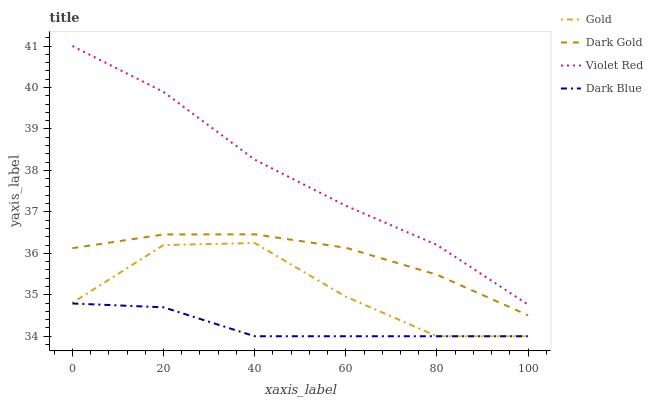Does Dark Blue have the minimum area under the curve?
Answer yes or no. Yes. Does Violet Red have the maximum area under the curve?
Answer yes or no. Yes. Does Gold have the minimum area under the curve?
Answer yes or no. No. Does Gold have the maximum area under the curve?
Answer yes or no. No. Is Dark Blue the smoothest?
Answer yes or no. Yes. Is Gold the roughest?
Answer yes or no. Yes. Is Violet Red the smoothest?
Answer yes or no. No. Is Violet Red the roughest?
Answer yes or no. No. Does Dark Blue have the lowest value?
Answer yes or no. Yes. Does Violet Red have the lowest value?
Answer yes or no. No. Does Violet Red have the highest value?
Answer yes or no. Yes. Does Gold have the highest value?
Answer yes or no. No. Is Dark Gold less than Violet Red?
Answer yes or no. Yes. Is Dark Gold greater than Dark Blue?
Answer yes or no. Yes. Does Gold intersect Dark Blue?
Answer yes or no. Yes. Is Gold less than Dark Blue?
Answer yes or no. No. Is Gold greater than Dark Blue?
Answer yes or no. No. Does Dark Gold intersect Violet Red?
Answer yes or no. No. 